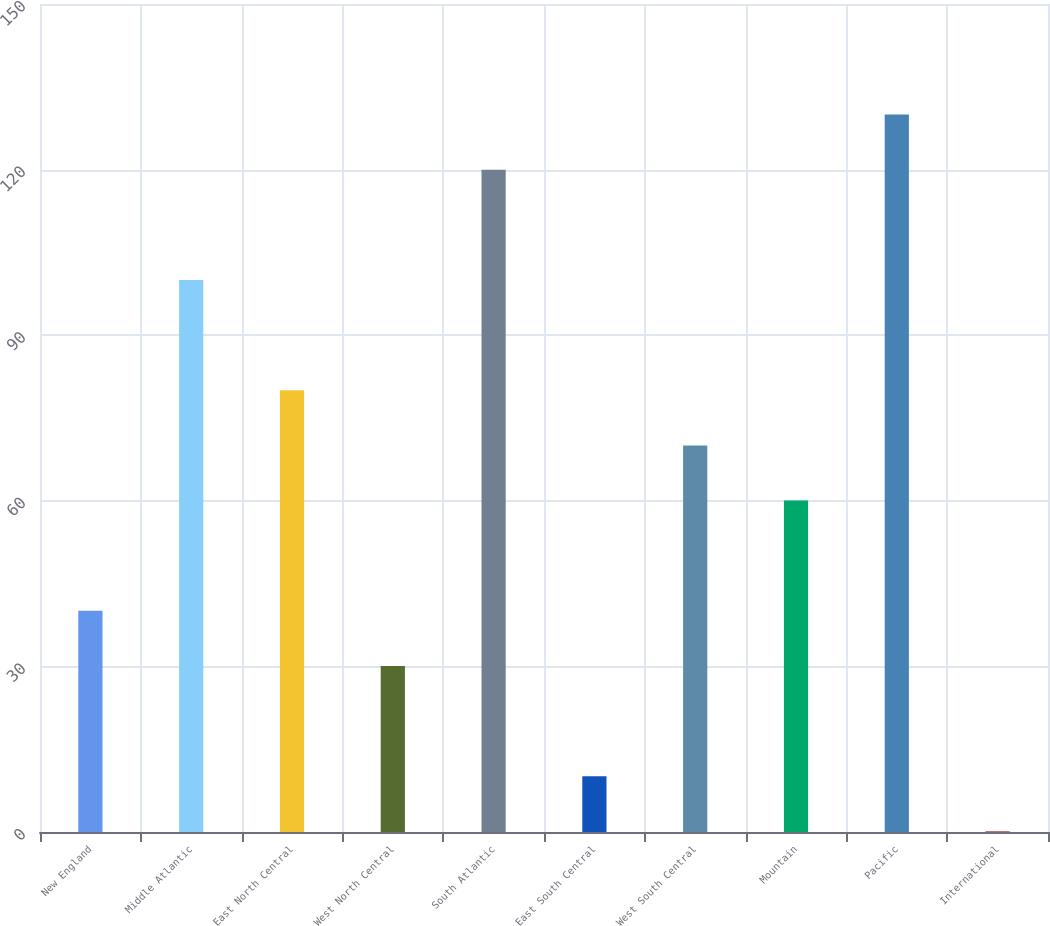Convert chart. <chart><loc_0><loc_0><loc_500><loc_500><bar_chart><fcel>New England<fcel>Middle Atlantic<fcel>East North Central<fcel>West North Central<fcel>South Atlantic<fcel>East South Central<fcel>West South Central<fcel>Mountain<fcel>Pacific<fcel>International<nl><fcel>40.06<fcel>100<fcel>80.02<fcel>30.07<fcel>119.98<fcel>10.09<fcel>70.03<fcel>60.04<fcel>129.97<fcel>0.1<nl></chart> 